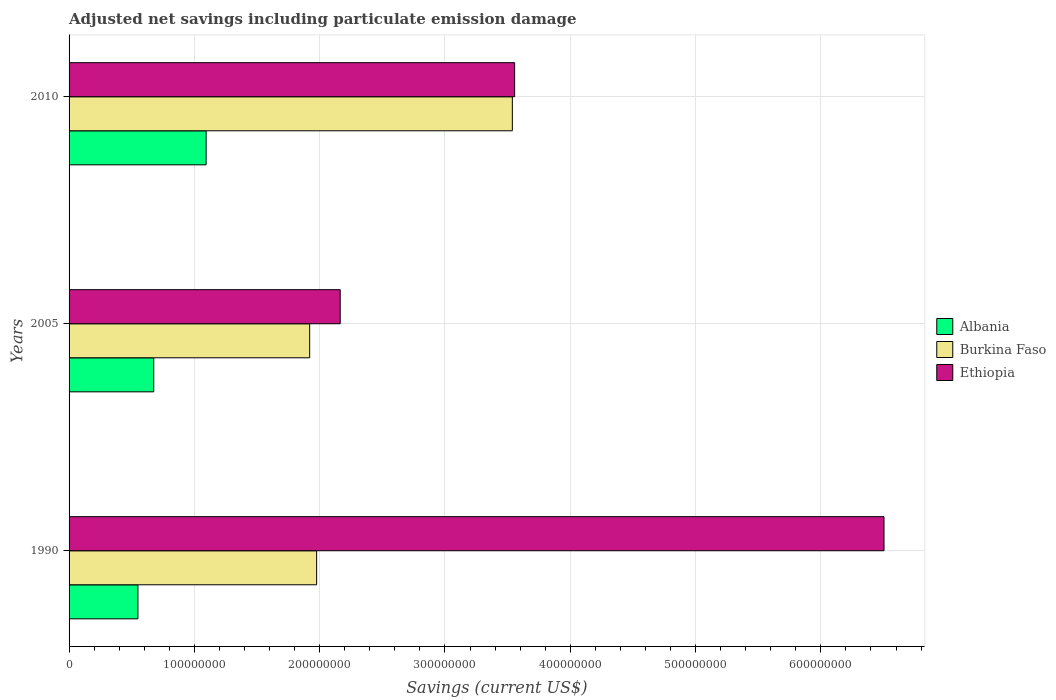Are the number of bars on each tick of the Y-axis equal?
Give a very brief answer. Yes. What is the label of the 3rd group of bars from the top?
Provide a succinct answer. 1990. In how many cases, is the number of bars for a given year not equal to the number of legend labels?
Ensure brevity in your answer.  0. What is the net savings in Albania in 2005?
Offer a terse response. 6.76e+07. Across all years, what is the maximum net savings in Ethiopia?
Ensure brevity in your answer.  6.50e+08. Across all years, what is the minimum net savings in Burkina Faso?
Your response must be concise. 1.92e+08. In which year was the net savings in Ethiopia maximum?
Your answer should be compact. 1990. In which year was the net savings in Ethiopia minimum?
Make the answer very short. 2005. What is the total net savings in Albania in the graph?
Ensure brevity in your answer.  2.32e+08. What is the difference between the net savings in Burkina Faso in 1990 and that in 2010?
Your answer should be compact. -1.56e+08. What is the difference between the net savings in Burkina Faso in 1990 and the net savings in Albania in 2005?
Your answer should be very brief. 1.30e+08. What is the average net savings in Burkina Faso per year?
Provide a short and direct response. 2.48e+08. In the year 2005, what is the difference between the net savings in Ethiopia and net savings in Albania?
Your answer should be very brief. 1.49e+08. In how many years, is the net savings in Albania greater than 600000000 US$?
Your answer should be very brief. 0. What is the ratio of the net savings in Albania in 2005 to that in 2010?
Your response must be concise. 0.62. Is the net savings in Albania in 1990 less than that in 2010?
Provide a short and direct response. Yes. Is the difference between the net savings in Ethiopia in 2005 and 2010 greater than the difference between the net savings in Albania in 2005 and 2010?
Ensure brevity in your answer.  No. What is the difference between the highest and the second highest net savings in Ethiopia?
Your answer should be very brief. 2.95e+08. What is the difference between the highest and the lowest net savings in Burkina Faso?
Your response must be concise. 1.62e+08. In how many years, is the net savings in Albania greater than the average net savings in Albania taken over all years?
Ensure brevity in your answer.  1. What does the 2nd bar from the top in 1990 represents?
Your response must be concise. Burkina Faso. What does the 1st bar from the bottom in 2010 represents?
Provide a succinct answer. Albania. Is it the case that in every year, the sum of the net savings in Burkina Faso and net savings in Ethiopia is greater than the net savings in Albania?
Provide a short and direct response. Yes. How many bars are there?
Your answer should be very brief. 9. Are all the bars in the graph horizontal?
Make the answer very short. Yes. How many years are there in the graph?
Give a very brief answer. 3. Does the graph contain any zero values?
Make the answer very short. No. How many legend labels are there?
Your response must be concise. 3. What is the title of the graph?
Your answer should be compact. Adjusted net savings including particulate emission damage. Does "Solomon Islands" appear as one of the legend labels in the graph?
Provide a succinct answer. No. What is the label or title of the X-axis?
Your answer should be compact. Savings (current US$). What is the label or title of the Y-axis?
Offer a very short reply. Years. What is the Savings (current US$) in Albania in 1990?
Provide a short and direct response. 5.50e+07. What is the Savings (current US$) of Burkina Faso in 1990?
Make the answer very short. 1.98e+08. What is the Savings (current US$) of Ethiopia in 1990?
Offer a very short reply. 6.50e+08. What is the Savings (current US$) of Albania in 2005?
Offer a terse response. 6.76e+07. What is the Savings (current US$) of Burkina Faso in 2005?
Provide a succinct answer. 1.92e+08. What is the Savings (current US$) of Ethiopia in 2005?
Provide a succinct answer. 2.16e+08. What is the Savings (current US$) of Albania in 2010?
Provide a short and direct response. 1.09e+08. What is the Savings (current US$) of Burkina Faso in 2010?
Offer a terse response. 3.54e+08. What is the Savings (current US$) in Ethiopia in 2010?
Your answer should be compact. 3.56e+08. Across all years, what is the maximum Savings (current US$) of Albania?
Provide a succinct answer. 1.09e+08. Across all years, what is the maximum Savings (current US$) in Burkina Faso?
Provide a short and direct response. 3.54e+08. Across all years, what is the maximum Savings (current US$) in Ethiopia?
Make the answer very short. 6.50e+08. Across all years, what is the minimum Savings (current US$) of Albania?
Provide a succinct answer. 5.50e+07. Across all years, what is the minimum Savings (current US$) of Burkina Faso?
Your answer should be compact. 1.92e+08. Across all years, what is the minimum Savings (current US$) of Ethiopia?
Make the answer very short. 2.16e+08. What is the total Savings (current US$) in Albania in the graph?
Offer a terse response. 2.32e+08. What is the total Savings (current US$) in Burkina Faso in the graph?
Offer a terse response. 7.43e+08. What is the total Savings (current US$) of Ethiopia in the graph?
Give a very brief answer. 1.22e+09. What is the difference between the Savings (current US$) in Albania in 1990 and that in 2005?
Provide a short and direct response. -1.26e+07. What is the difference between the Savings (current US$) in Burkina Faso in 1990 and that in 2005?
Provide a short and direct response. 5.55e+06. What is the difference between the Savings (current US$) of Ethiopia in 1990 and that in 2005?
Your response must be concise. 4.34e+08. What is the difference between the Savings (current US$) in Albania in 1990 and that in 2010?
Your answer should be very brief. -5.44e+07. What is the difference between the Savings (current US$) of Burkina Faso in 1990 and that in 2010?
Your answer should be compact. -1.56e+08. What is the difference between the Savings (current US$) in Ethiopia in 1990 and that in 2010?
Your response must be concise. 2.95e+08. What is the difference between the Savings (current US$) in Albania in 2005 and that in 2010?
Keep it short and to the point. -4.18e+07. What is the difference between the Savings (current US$) of Burkina Faso in 2005 and that in 2010?
Provide a short and direct response. -1.62e+08. What is the difference between the Savings (current US$) of Ethiopia in 2005 and that in 2010?
Your response must be concise. -1.39e+08. What is the difference between the Savings (current US$) in Albania in 1990 and the Savings (current US$) in Burkina Faso in 2005?
Give a very brief answer. -1.37e+08. What is the difference between the Savings (current US$) of Albania in 1990 and the Savings (current US$) of Ethiopia in 2005?
Offer a terse response. -1.61e+08. What is the difference between the Savings (current US$) of Burkina Faso in 1990 and the Savings (current US$) of Ethiopia in 2005?
Keep it short and to the point. -1.88e+07. What is the difference between the Savings (current US$) of Albania in 1990 and the Savings (current US$) of Burkina Faso in 2010?
Keep it short and to the point. -2.99e+08. What is the difference between the Savings (current US$) of Albania in 1990 and the Savings (current US$) of Ethiopia in 2010?
Give a very brief answer. -3.01e+08. What is the difference between the Savings (current US$) in Burkina Faso in 1990 and the Savings (current US$) in Ethiopia in 2010?
Keep it short and to the point. -1.58e+08. What is the difference between the Savings (current US$) of Albania in 2005 and the Savings (current US$) of Burkina Faso in 2010?
Offer a very short reply. -2.86e+08. What is the difference between the Savings (current US$) in Albania in 2005 and the Savings (current US$) in Ethiopia in 2010?
Provide a short and direct response. -2.88e+08. What is the difference between the Savings (current US$) of Burkina Faso in 2005 and the Savings (current US$) of Ethiopia in 2010?
Offer a very short reply. -1.64e+08. What is the average Savings (current US$) of Albania per year?
Offer a very short reply. 7.73e+07. What is the average Savings (current US$) in Burkina Faso per year?
Offer a terse response. 2.48e+08. What is the average Savings (current US$) of Ethiopia per year?
Offer a terse response. 4.07e+08. In the year 1990, what is the difference between the Savings (current US$) of Albania and Savings (current US$) of Burkina Faso?
Keep it short and to the point. -1.43e+08. In the year 1990, what is the difference between the Savings (current US$) in Albania and Savings (current US$) in Ethiopia?
Provide a succinct answer. -5.95e+08. In the year 1990, what is the difference between the Savings (current US$) in Burkina Faso and Savings (current US$) in Ethiopia?
Provide a short and direct response. -4.53e+08. In the year 2005, what is the difference between the Savings (current US$) in Albania and Savings (current US$) in Burkina Faso?
Your answer should be very brief. -1.24e+08. In the year 2005, what is the difference between the Savings (current US$) of Albania and Savings (current US$) of Ethiopia?
Your answer should be very brief. -1.49e+08. In the year 2005, what is the difference between the Savings (current US$) in Burkina Faso and Savings (current US$) in Ethiopia?
Your answer should be very brief. -2.44e+07. In the year 2010, what is the difference between the Savings (current US$) of Albania and Savings (current US$) of Burkina Faso?
Your response must be concise. -2.44e+08. In the year 2010, what is the difference between the Savings (current US$) of Albania and Savings (current US$) of Ethiopia?
Keep it short and to the point. -2.46e+08. In the year 2010, what is the difference between the Savings (current US$) in Burkina Faso and Savings (current US$) in Ethiopia?
Give a very brief answer. -1.84e+06. What is the ratio of the Savings (current US$) of Albania in 1990 to that in 2005?
Provide a succinct answer. 0.81. What is the ratio of the Savings (current US$) in Burkina Faso in 1990 to that in 2005?
Provide a succinct answer. 1.03. What is the ratio of the Savings (current US$) of Ethiopia in 1990 to that in 2005?
Make the answer very short. 3.01. What is the ratio of the Savings (current US$) in Albania in 1990 to that in 2010?
Your answer should be very brief. 0.5. What is the ratio of the Savings (current US$) of Burkina Faso in 1990 to that in 2010?
Give a very brief answer. 0.56. What is the ratio of the Savings (current US$) of Ethiopia in 1990 to that in 2010?
Provide a succinct answer. 1.83. What is the ratio of the Savings (current US$) in Albania in 2005 to that in 2010?
Keep it short and to the point. 0.62. What is the ratio of the Savings (current US$) in Burkina Faso in 2005 to that in 2010?
Offer a very short reply. 0.54. What is the ratio of the Savings (current US$) of Ethiopia in 2005 to that in 2010?
Offer a very short reply. 0.61. What is the difference between the highest and the second highest Savings (current US$) in Albania?
Your answer should be compact. 4.18e+07. What is the difference between the highest and the second highest Savings (current US$) in Burkina Faso?
Your answer should be very brief. 1.56e+08. What is the difference between the highest and the second highest Savings (current US$) of Ethiopia?
Keep it short and to the point. 2.95e+08. What is the difference between the highest and the lowest Savings (current US$) in Albania?
Make the answer very short. 5.44e+07. What is the difference between the highest and the lowest Savings (current US$) in Burkina Faso?
Keep it short and to the point. 1.62e+08. What is the difference between the highest and the lowest Savings (current US$) in Ethiopia?
Your response must be concise. 4.34e+08. 